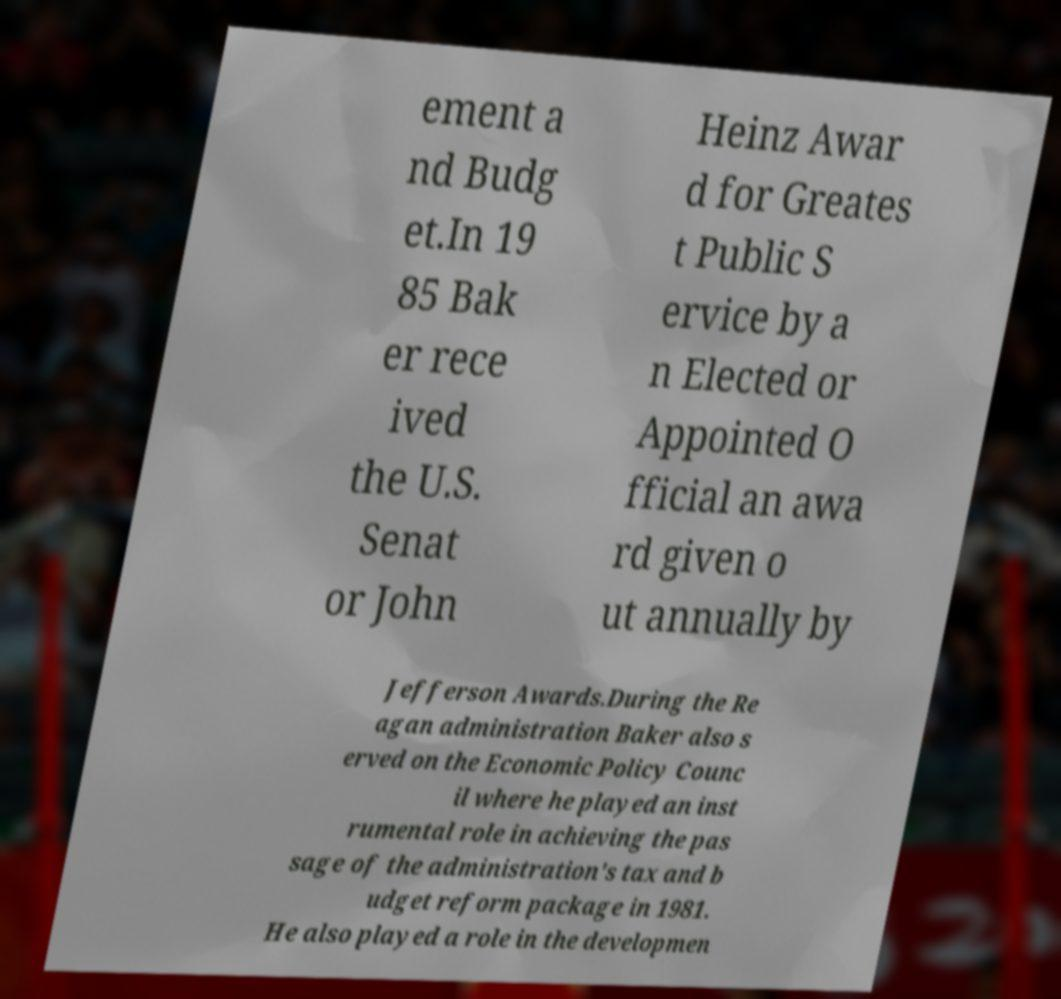Please read and relay the text visible in this image. What does it say? ement a nd Budg et.In 19 85 Bak er rece ived the U.S. Senat or John Heinz Awar d for Greates t Public S ervice by a n Elected or Appointed O fficial an awa rd given o ut annually by Jefferson Awards.During the Re agan administration Baker also s erved on the Economic Policy Counc il where he played an inst rumental role in achieving the pas sage of the administration's tax and b udget reform package in 1981. He also played a role in the developmen 